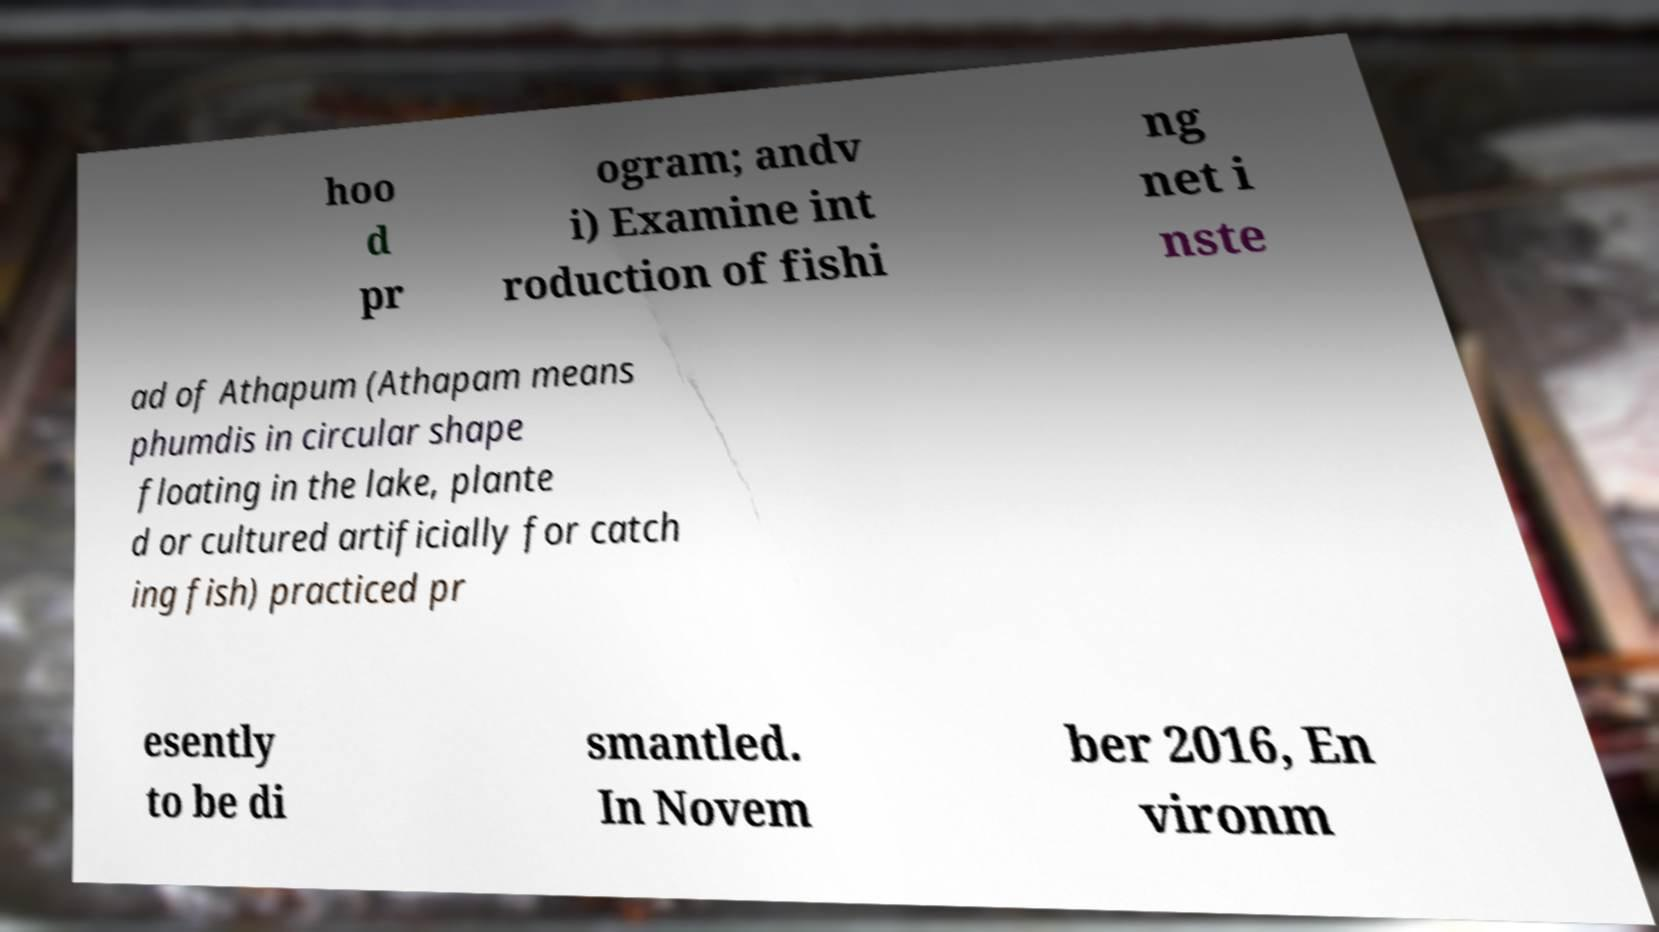For documentation purposes, I need the text within this image transcribed. Could you provide that? hoo d pr ogram; andv i) Examine int roduction of fishi ng net i nste ad of Athapum (Athapam means phumdis in circular shape floating in the lake, plante d or cultured artificially for catch ing fish) practiced pr esently to be di smantled. In Novem ber 2016, En vironm 